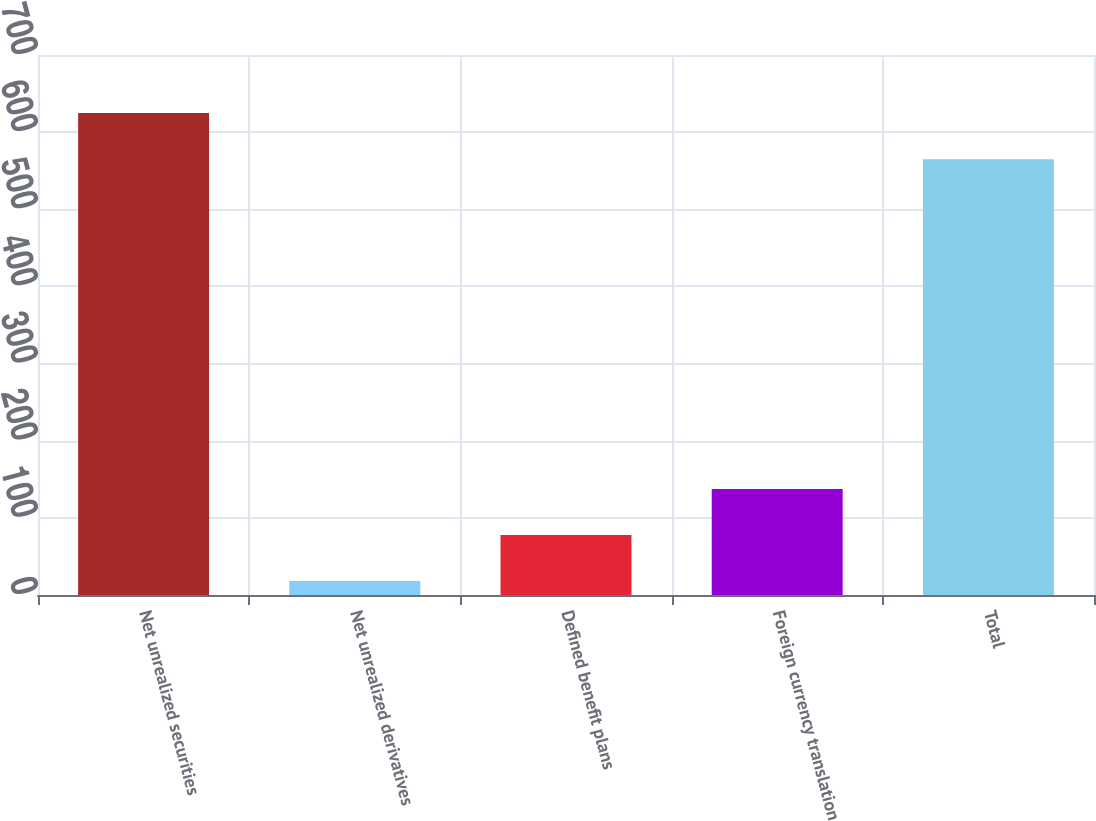Convert chart. <chart><loc_0><loc_0><loc_500><loc_500><bar_chart><fcel>Net unrealized securities<fcel>Net unrealized derivatives<fcel>Defined benefit plans<fcel>Foreign currency translation<fcel>Total<nl><fcel>624.7<fcel>18<fcel>77.7<fcel>137.4<fcel>565<nl></chart> 